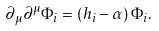Convert formula to latex. <formula><loc_0><loc_0><loc_500><loc_500>\partial _ { \mu } \partial ^ { \mu } \Phi _ { i } = ( h _ { i } - \alpha ) \, \Phi _ { i } .</formula> 